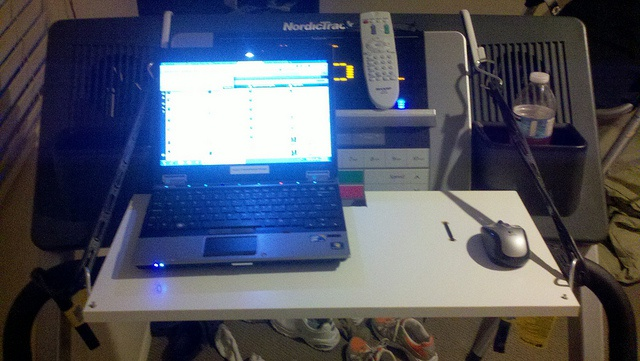Describe the objects in this image and their specific colors. I can see laptop in maroon, white, blue, and navy tones, dining table in maroon, darkgray, lightgray, gray, and navy tones, remote in maroon and gray tones, bottle in maroon, gray, and black tones, and mouse in maroon, black, gray, and darkgray tones in this image. 